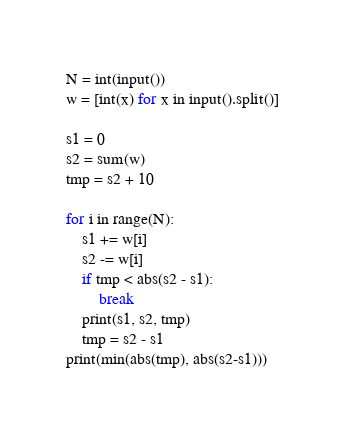Convert code to text. <code><loc_0><loc_0><loc_500><loc_500><_Python_>N = int(input())
w = [int(x) for x in input().split()]

s1 = 0
s2 = sum(w)
tmp = s2 + 10

for i in range(N):
    s1 += w[i]
    s2 -= w[i]
    if tmp < abs(s2 - s1):
        break
    print(s1, s2, tmp)
    tmp = s2 - s1
print(min(abs(tmp), abs(s2-s1)))</code> 